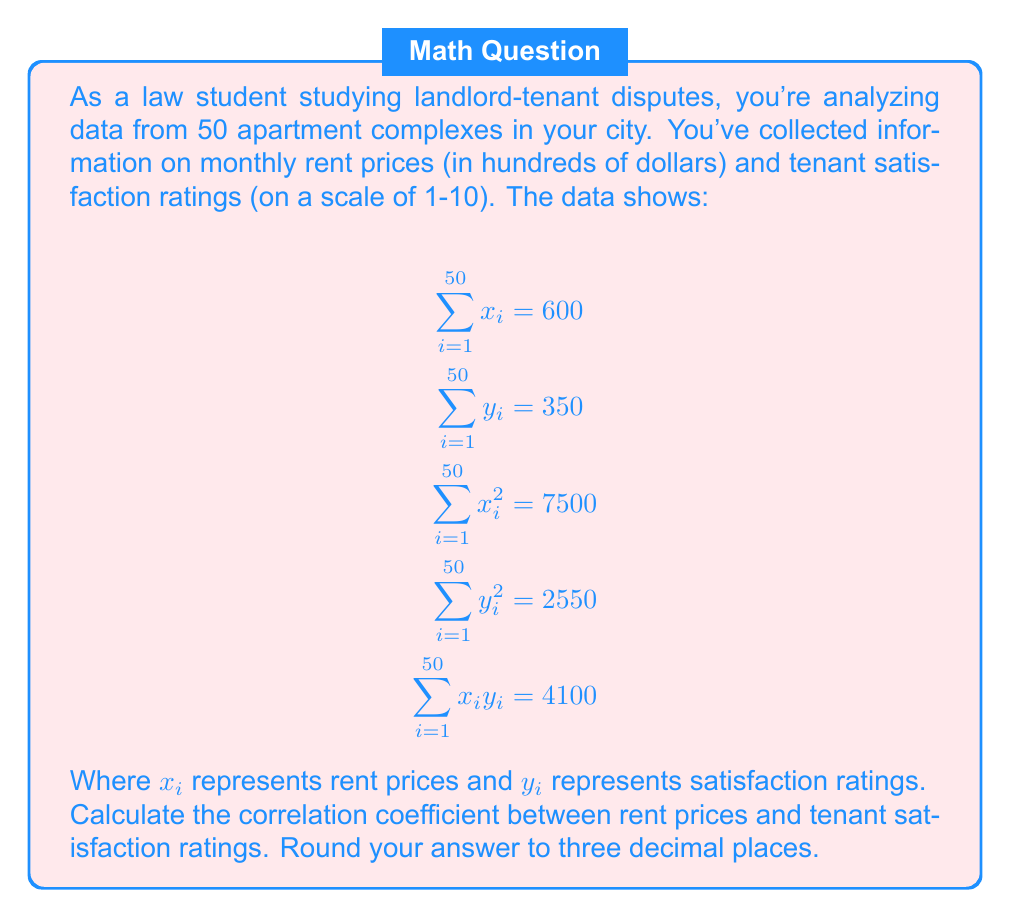Help me with this question. To calculate the correlation coefficient, we'll use the formula:

$$r = \frac{n\sum x_iy_i - (\sum x_i)(\sum y_i)}{\sqrt{[n\sum x_i^2 - (\sum x_i)^2][n\sum y_i^2 - (\sum y_i)^2]}}$$

Where $n$ is the number of data points (50 in this case).

Step 1: Calculate $n\sum x_iy_i$
$50 \times 4100 = 205000$

Step 2: Calculate $(\sum x_i)(\sum y_i)$
$600 \times 350 = 210000$

Step 3: Calculate the numerator
$205000 - 210000 = -5000$

Step 4: Calculate $n\sum x_i^2$ and $(\sum x_i)^2$
$50 \times 7500 = 375000$
$600^2 = 360000$

Step 5: Calculate $n\sum y_i^2$ and $(\sum y_i)^2$
$50 \times 2550 = 127500$
$350^2 = 122500$

Step 6: Calculate the denominator
$\sqrt{(375000 - 360000)(127500 - 122500)}$
$= \sqrt{(15000)(5000)}$
$= \sqrt{75000000}$
$= 8660.254$

Step 7: Divide the numerator by the denominator
$r = \frac{-5000}{8660.254} = -0.577$

Rounding to three decimal places: $-0.577$
Answer: $-0.577$ 